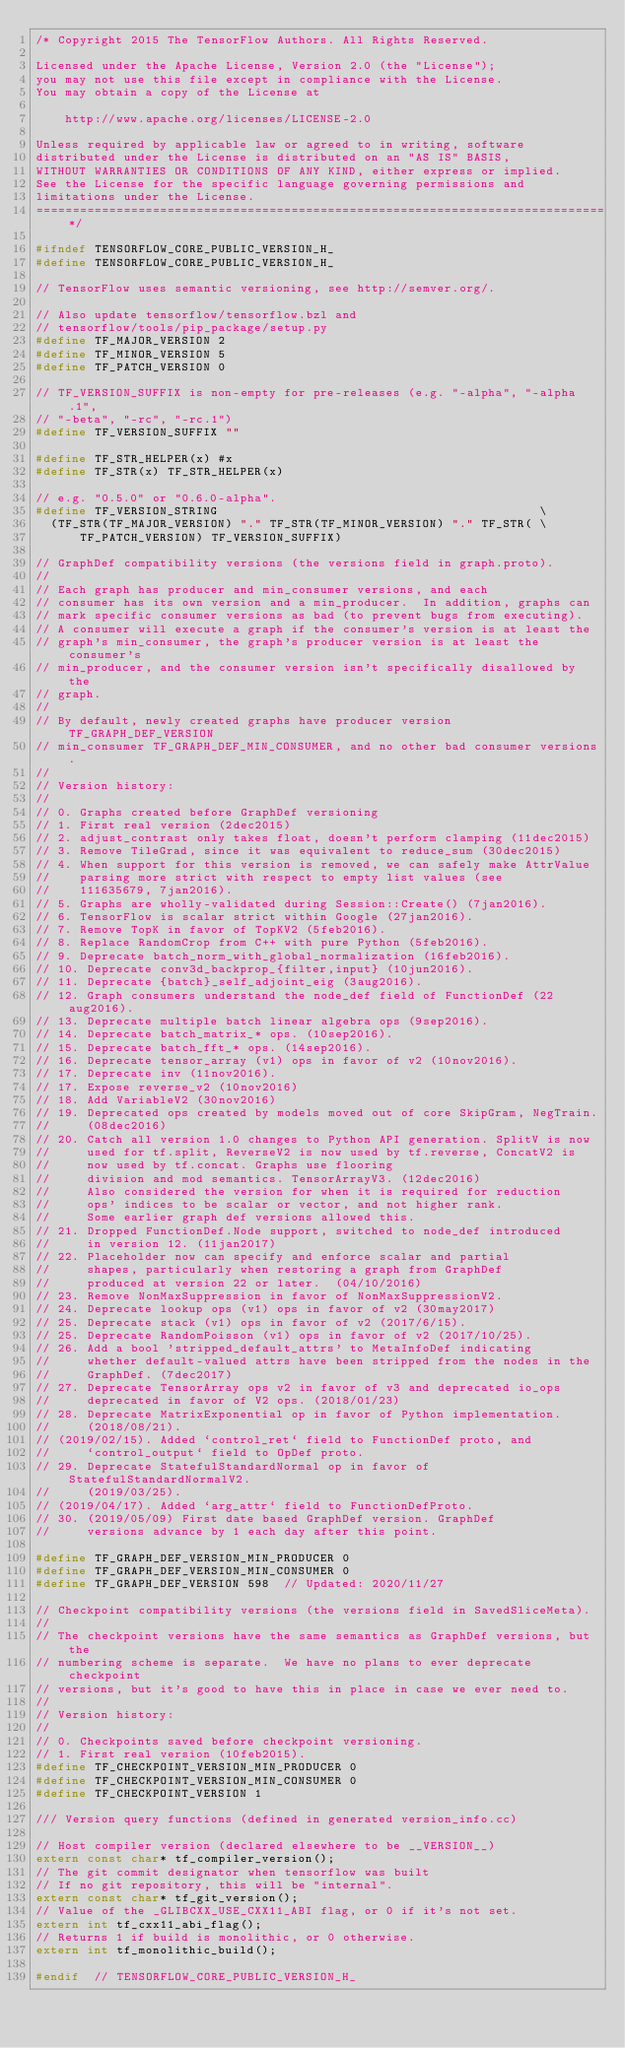Convert code to text. <code><loc_0><loc_0><loc_500><loc_500><_C_>/* Copyright 2015 The TensorFlow Authors. All Rights Reserved.

Licensed under the Apache License, Version 2.0 (the "License");
you may not use this file except in compliance with the License.
You may obtain a copy of the License at

    http://www.apache.org/licenses/LICENSE-2.0

Unless required by applicable law or agreed to in writing, software
distributed under the License is distributed on an "AS IS" BASIS,
WITHOUT WARRANTIES OR CONDITIONS OF ANY KIND, either express or implied.
See the License for the specific language governing permissions and
limitations under the License.
==============================================================================*/

#ifndef TENSORFLOW_CORE_PUBLIC_VERSION_H_
#define TENSORFLOW_CORE_PUBLIC_VERSION_H_

// TensorFlow uses semantic versioning, see http://semver.org/.

// Also update tensorflow/tensorflow.bzl and
// tensorflow/tools/pip_package/setup.py
#define TF_MAJOR_VERSION 2
#define TF_MINOR_VERSION 5
#define TF_PATCH_VERSION 0

// TF_VERSION_SUFFIX is non-empty for pre-releases (e.g. "-alpha", "-alpha.1",
// "-beta", "-rc", "-rc.1")
#define TF_VERSION_SUFFIX ""

#define TF_STR_HELPER(x) #x
#define TF_STR(x) TF_STR_HELPER(x)

// e.g. "0.5.0" or "0.6.0-alpha".
#define TF_VERSION_STRING                                            \
  (TF_STR(TF_MAJOR_VERSION) "." TF_STR(TF_MINOR_VERSION) "." TF_STR( \
      TF_PATCH_VERSION) TF_VERSION_SUFFIX)

// GraphDef compatibility versions (the versions field in graph.proto).
//
// Each graph has producer and min_consumer versions, and each
// consumer has its own version and a min_producer.  In addition, graphs can
// mark specific consumer versions as bad (to prevent bugs from executing).
// A consumer will execute a graph if the consumer's version is at least the
// graph's min_consumer, the graph's producer version is at least the consumer's
// min_producer, and the consumer version isn't specifically disallowed by the
// graph.
//
// By default, newly created graphs have producer version TF_GRAPH_DEF_VERSION
// min_consumer TF_GRAPH_DEF_MIN_CONSUMER, and no other bad consumer versions.
//
// Version history:
//
// 0. Graphs created before GraphDef versioning
// 1. First real version (2dec2015)
// 2. adjust_contrast only takes float, doesn't perform clamping (11dec2015)
// 3. Remove TileGrad, since it was equivalent to reduce_sum (30dec2015)
// 4. When support for this version is removed, we can safely make AttrValue
//    parsing more strict with respect to empty list values (see
//    111635679, 7jan2016).
// 5. Graphs are wholly-validated during Session::Create() (7jan2016).
// 6. TensorFlow is scalar strict within Google (27jan2016).
// 7. Remove TopK in favor of TopKV2 (5feb2016).
// 8. Replace RandomCrop from C++ with pure Python (5feb2016).
// 9. Deprecate batch_norm_with_global_normalization (16feb2016).
// 10. Deprecate conv3d_backprop_{filter,input} (10jun2016).
// 11. Deprecate {batch}_self_adjoint_eig (3aug2016).
// 12. Graph consumers understand the node_def field of FunctionDef (22aug2016).
// 13. Deprecate multiple batch linear algebra ops (9sep2016).
// 14. Deprecate batch_matrix_* ops. (10sep2016).
// 15. Deprecate batch_fft_* ops. (14sep2016).
// 16. Deprecate tensor_array (v1) ops in favor of v2 (10nov2016).
// 17. Deprecate inv (11nov2016).
// 17. Expose reverse_v2 (10nov2016)
// 18. Add VariableV2 (30nov2016)
// 19. Deprecated ops created by models moved out of core SkipGram, NegTrain.
//     (08dec2016)
// 20. Catch all version 1.0 changes to Python API generation. SplitV is now
//     used for tf.split, ReverseV2 is now used by tf.reverse, ConcatV2 is
//     now used by tf.concat. Graphs use flooring
//     division and mod semantics. TensorArrayV3. (12dec2016)
//     Also considered the version for when it is required for reduction
//     ops' indices to be scalar or vector, and not higher rank.
//     Some earlier graph def versions allowed this.
// 21. Dropped FunctionDef.Node support, switched to node_def introduced
//     in version 12. (11jan2017)
// 22. Placeholder now can specify and enforce scalar and partial
//     shapes, particularly when restoring a graph from GraphDef
//     produced at version 22 or later.  (04/10/2016)
// 23. Remove NonMaxSuppression in favor of NonMaxSuppressionV2.
// 24. Deprecate lookup ops (v1) ops in favor of v2 (30may2017)
// 25. Deprecate stack (v1) ops in favor of v2 (2017/6/15).
// 25. Deprecate RandomPoisson (v1) ops in favor of v2 (2017/10/25).
// 26. Add a bool 'stripped_default_attrs' to MetaInfoDef indicating
//     whether default-valued attrs have been stripped from the nodes in the
//     GraphDef. (7dec2017)
// 27. Deprecate TensorArray ops v2 in favor of v3 and deprecated io_ops
//     deprecated in favor of V2 ops. (2018/01/23)
// 28. Deprecate MatrixExponential op in favor of Python implementation.
//     (2018/08/21).
// (2019/02/15). Added `control_ret` field to FunctionDef proto, and
//     `control_output` field to OpDef proto.
// 29. Deprecate StatefulStandardNormal op in favor of StatefulStandardNormalV2.
//     (2019/03/25).
// (2019/04/17). Added `arg_attr` field to FunctionDefProto.
// 30. (2019/05/09) First date based GraphDef version. GraphDef
//     versions advance by 1 each day after this point.

#define TF_GRAPH_DEF_VERSION_MIN_PRODUCER 0
#define TF_GRAPH_DEF_VERSION_MIN_CONSUMER 0
#define TF_GRAPH_DEF_VERSION 598  // Updated: 2020/11/27

// Checkpoint compatibility versions (the versions field in SavedSliceMeta).
//
// The checkpoint versions have the same semantics as GraphDef versions, but the
// numbering scheme is separate.  We have no plans to ever deprecate checkpoint
// versions, but it's good to have this in place in case we ever need to.
//
// Version history:
//
// 0. Checkpoints saved before checkpoint versioning.
// 1. First real version (10feb2015).
#define TF_CHECKPOINT_VERSION_MIN_PRODUCER 0
#define TF_CHECKPOINT_VERSION_MIN_CONSUMER 0
#define TF_CHECKPOINT_VERSION 1

/// Version query functions (defined in generated version_info.cc)

// Host compiler version (declared elsewhere to be __VERSION__)
extern const char* tf_compiler_version();
// The git commit designator when tensorflow was built
// If no git repository, this will be "internal".
extern const char* tf_git_version();
// Value of the _GLIBCXX_USE_CXX11_ABI flag, or 0 if it's not set.
extern int tf_cxx11_abi_flag();
// Returns 1 if build is monolithic, or 0 otherwise.
extern int tf_monolithic_build();

#endif  // TENSORFLOW_CORE_PUBLIC_VERSION_H_
</code> 